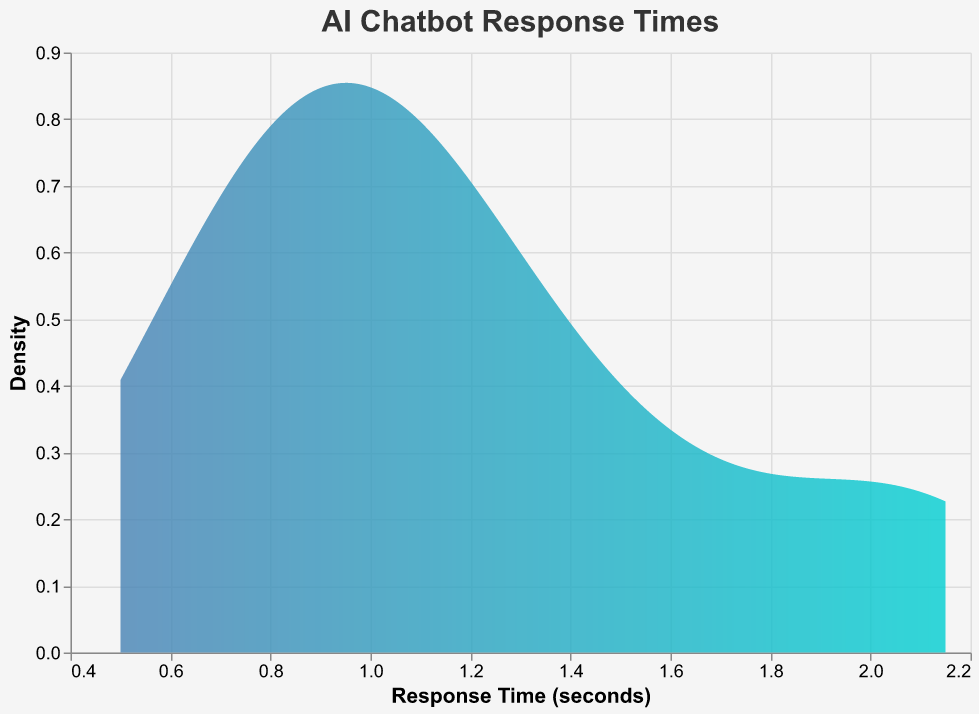what is the title of the plot? The title is displayed at the top of the plot and provides a summary of what the plot represents.
Answer: AI Chatbot Response Times What is the range of the x-axis (Response Time)? The x-axis, representing Response Time, starts from 0 seconds and extends to a value slightly above the highest response time shown in the plot.
Answer: 0 to slightly above 2.15 seconds How does the density of response times appear to change as the response time increases? By observing the density plot, we can see that the density starts high at lower response times and gradually decreases as the response time increases, with fewer chatbots having very high response times.
Answer: Decreases Which chatbot has the fastest response time? The chatbot with the fastest response time is the one with its Response Time value closest to 0 seconds.
Answer: ChatGPT What's the range of response times where the density is the highest? The highest density can be visually identified by the peak of the curve, which occurs at a certain range of response times.
Answer: Around 0.5 to 1.0 seconds How many chatbots have a response time of less than 1 second? Count the number of chatbots with a response time value less than 1 second from the data provided.
Answer: 6 chatbots Compare the response times of ChatGPT and Pandorabots. Identify the response times for both chatbots and compare the values directly. ChatGPT has the fastest response time, and Pandorabots has one of the slowest response times.
Answer: ChatGPT: 0.50 seconds, Pandorabots: 2.15 seconds What can be inferred about the overall distribution of chatbot response times? By examining the density plot as a whole, the overall distribution suggests that most chatbots have response times below 1.5 seconds, with a few exceptions having higher response times.
Answer: Most chatbots have response times below 1.5 seconds Which chatbot has a response time closest to the median of the plotted response times? The median response time splits the data in half. By identifying the middle value of the sorted response times, we find the chatbot with a response time close to that value. Sorted response times place Microsoft Bot Framework's response time of 1.20 seconds close to the median.
Answer: Microsoft Bot Framework What does the density value represent in the context of this plot? The density value on the y-axis represents the probability distribution of the response times. Higher density values indicate ranges where response times are more common among the chatbots.
Answer: Probability distribution 